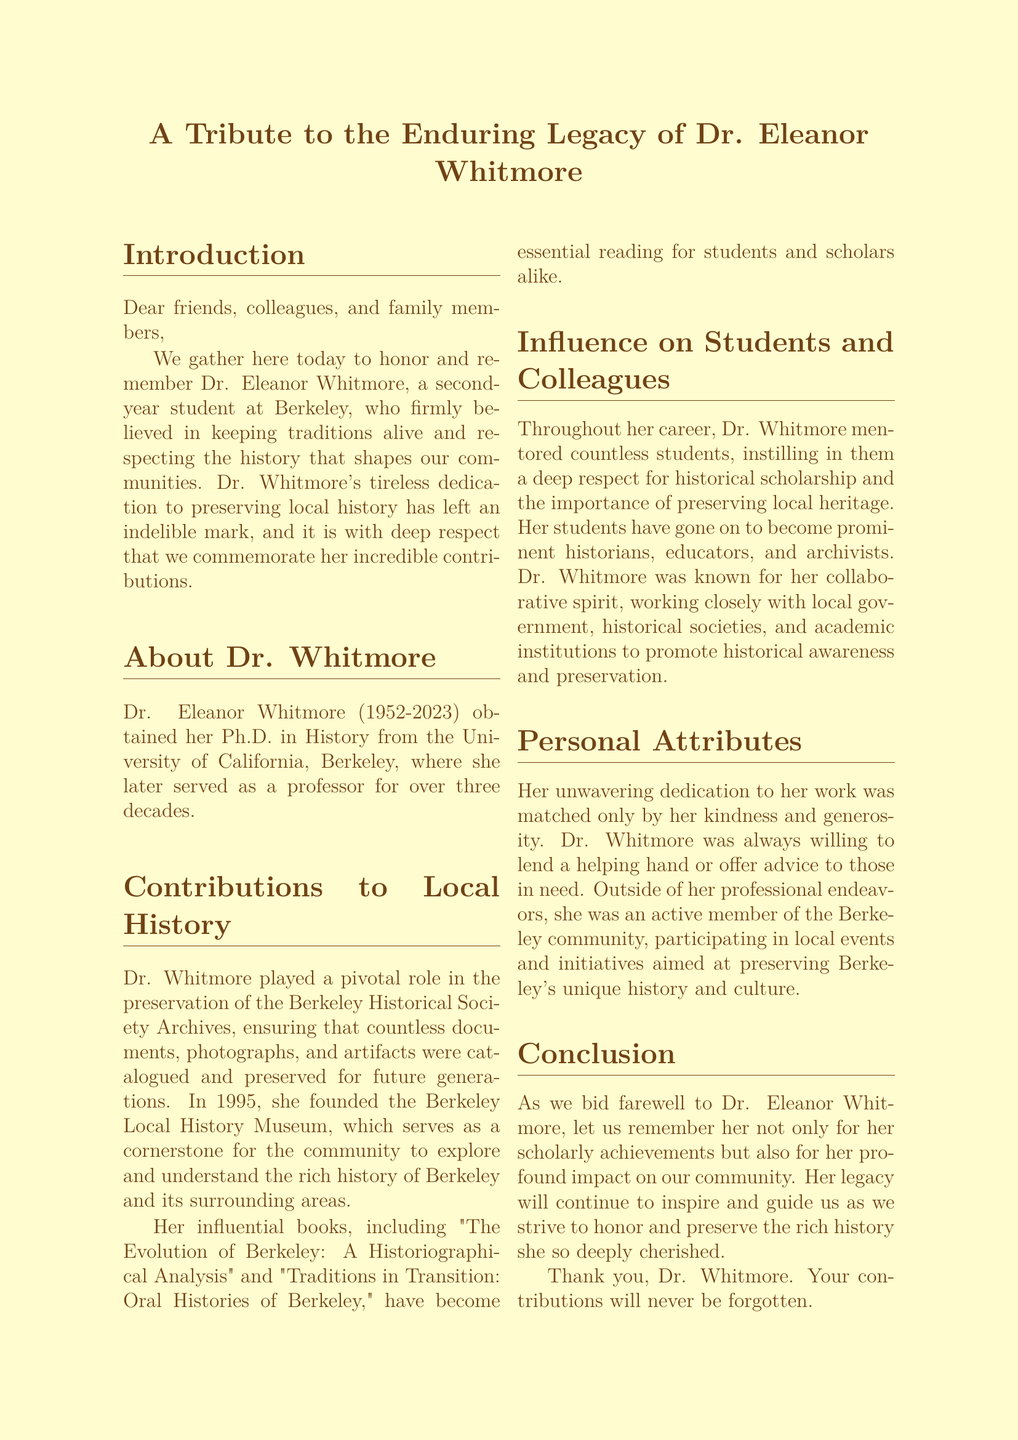what is the full name of the historian being honored? The document states that the historian being honored is Dr. Eleanor Whitmore.
Answer: Dr. Eleanor Whitmore what year was Dr. Whitmore born? The document mentions Dr. Whitmore's birth year as 1952.
Answer: 1952 what year did Dr. Whitmore pass away? According to the document, Dr. Whitmore passed away in 2023.
Answer: 2023 which museum did Dr. Whitmore found in 1995? The document states that Dr. Whitmore founded the Berkeley Local History Museum.
Answer: Berkeley Local History Museum how many decades did Dr. Whitmore serve as a professor? The document mentions that Dr. Whitmore served as a professor for over three decades.
Answer: over three decades what is the title of one of Dr. Whitmore's influential books? The document lists "The Evolution of Berkeley: A Historiographical Analysis" as one of her influential books.
Answer: The Evolution of Berkeley: A Historiographical Analysis how did Dr. Whitmore influence her students? The document states that she instilled a deep respect for historical scholarship in her students.
Answer: deep respect for historical scholarship what type of community initiatives did Dr. Whitmore participate in? The document mentions her participation in local events and initiatives aimed at preserving history and culture.
Answer: preserving history and culture what is the main purpose of this document? The document serves as a eulogy to honor and remember Dr. Whitmore's contributions and legacy.
Answer: honor and remember Dr. Whitmore's contributions and legacy 